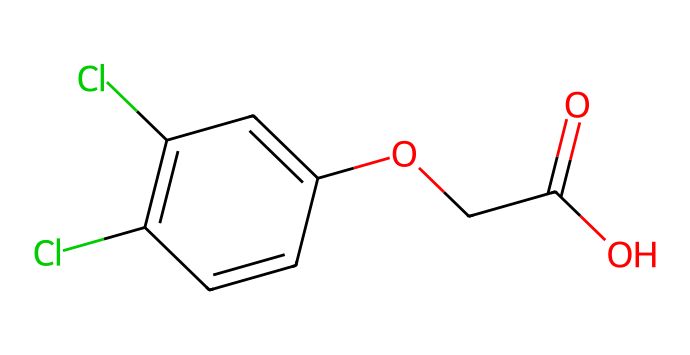What is the molecular formula of 2,4-D? The SMILES representation contains the symbols for carbon (C), hydrogen (H), oxygen (O), and chlorine (Cl). Counting the atoms: C (8), H (8), O (3), Cl (2) gives the molecular formula as C8H6Cl2O3.
Answer: C8H6Cl2O3 How many carbon atoms are present? By examining the SMILES representation, we can identify the number of carbon atoms present. Each 'C' indicates a carbon atom. In this structure, there are a total of 8 carbon atoms.
Answer: 8 What functional groups are present in 2,4-D? Looking at the SMILES, we can identify key features: the carboxylic acid (-COOH) group is indicated by "C(=O)O" and the ether linkage is represented by "OCC". Thus, the present functional groups are a carboxylic acid and an ether.
Answer: carboxylic acid, ether What type of herbicide is 2,4-D classified as? Considering the molecular structure and its function, 2,4-D is classified as a synthetic auxin, which mimics natural plant hormones that control growth.
Answer: synthetic auxin How many chlorine atoms are in 2,4-D? The SMILES representation contains two instances of the chlorine symbol 'Cl'. This indicates there are two chlorine atoms in the structure.
Answer: 2 What is the role of the chlorine atoms in herbicide function? The presence of chlorine atoms is significant as they contribute to the herbicide's ability to disrupt regular plant hormone signaling, leading to abnormal growth and death in target plants.
Answer: disrupt hormone signaling What does the presence of the carboxylic acid group indicate about 2,4-D's solubility? The carboxylic acid group enhances the solubility of 2,4-D in water, making it more effective for application as a herbicide since it can be easily absorbed by plants.
Answer: increased solubility 